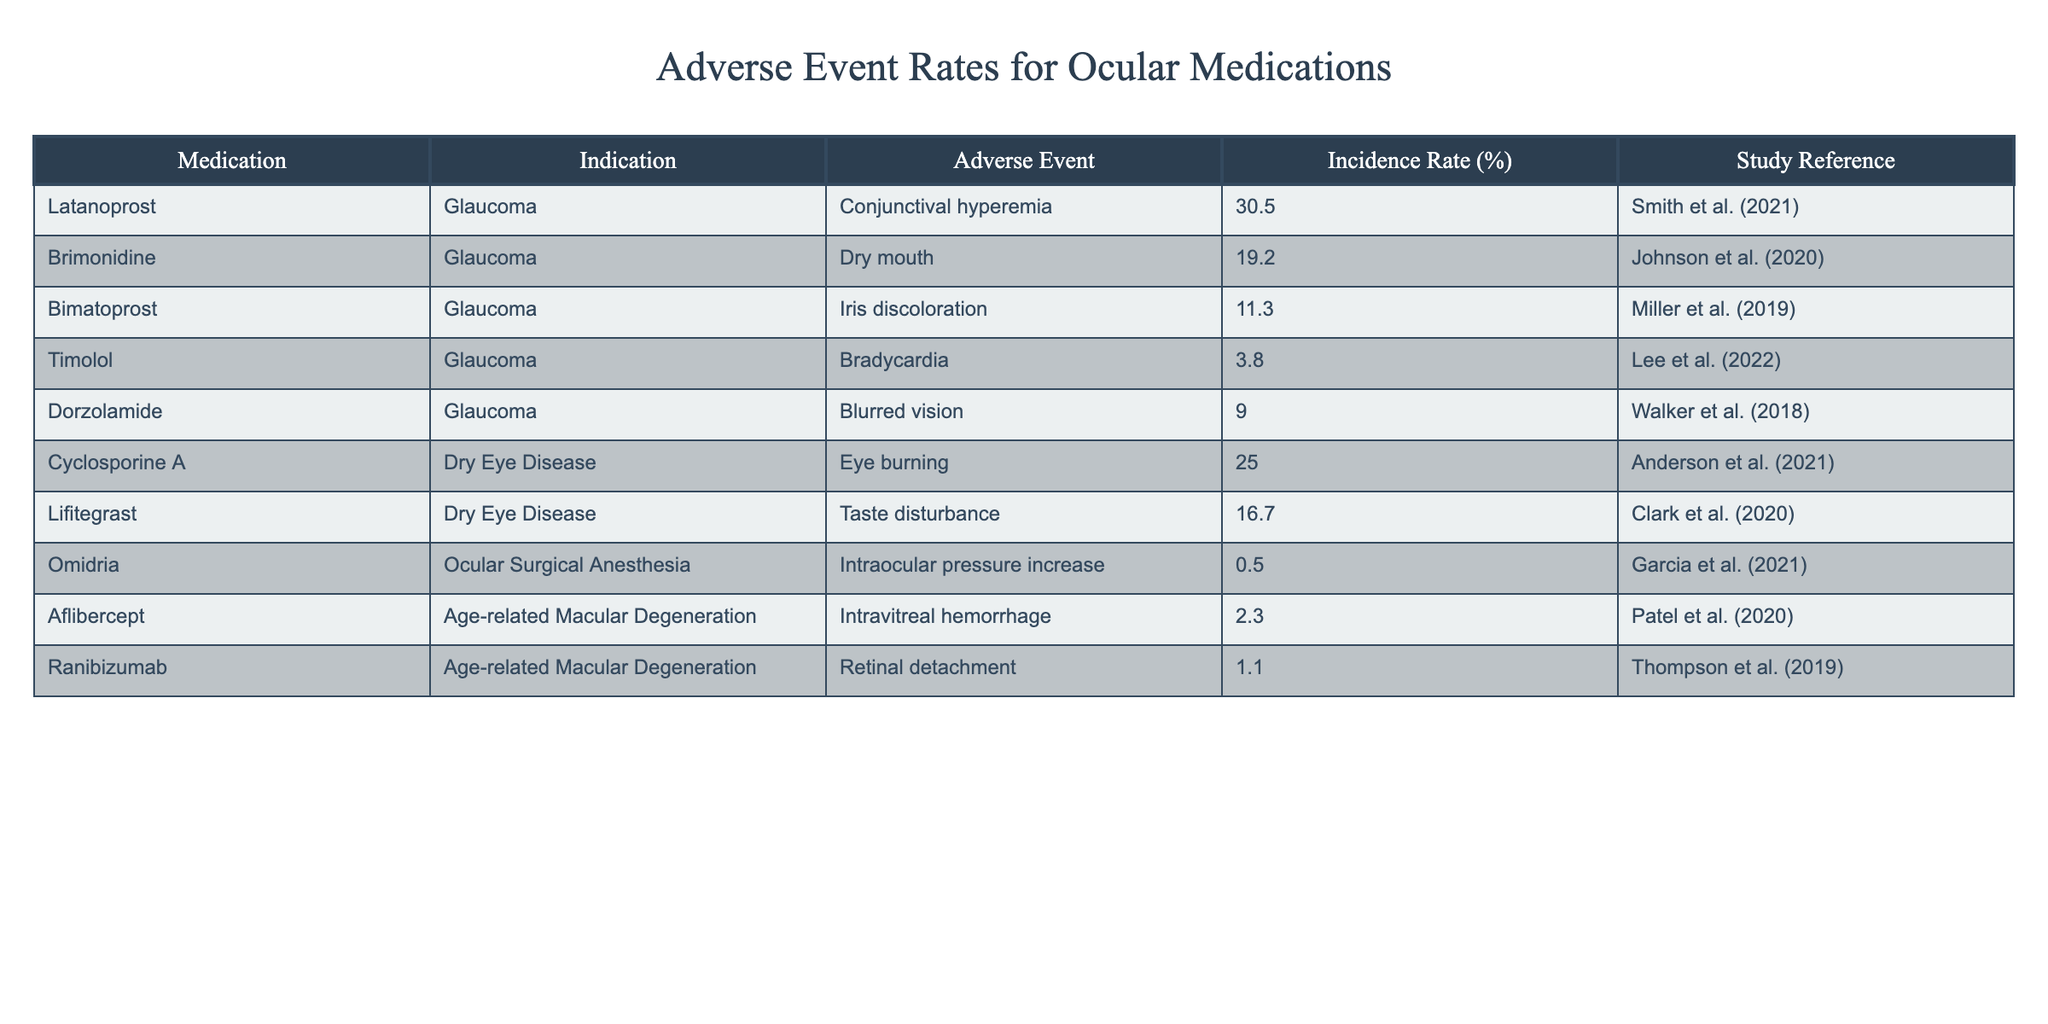What is the incidence rate of conjunctival hyperemia associated with Latanoprost? The table shows that the incidence rate of conjunctival hyperemia, which is an adverse event associated with Latanoprost, is 30.5%.
Answer: 30.5% Which ocular medication has the lowest incidence rate of adverse events, and what is that rate? According to the table, Omidria has the lowest incidence rate of adverse events at 0.5%.
Answer: 0.5% What is the difference in incidence rates between Cyclosporine A and Lifitegrast for their respective adverse events? Cyclosporine A has an incidence rate of 25.0% for eye burning, and Lifitegrast has an incidence rate of 16.7% for taste disturbance. The difference is 25.0% - 16.7% = 8.3%.
Answer: 8.3% Is it true that Ranibizumab has a higher incidence rate of adverse events compared to Timolol? Looking at the table, Ranibizumab has an incidence rate of 1.1% while Timolol has an incidence rate of 3.8%. Since 1.1% is less than 3.8%, the statement is false.
Answer: No What are the two medications listed for glaucoma, and how do their adverse event incidence rates compare? The table shows the medications for glaucoma: Latanoprost (30.5%) and Brimonidine (19.2%). Latanoprost has a higher incidence rate of adverse events compared to Brimonidine.
Answer: Latanoprost has a higher rate What is the total incidence rate of adverse events for all medications indicated for Dry Eye Disease? The incidents for Dry Eye Disease medications are Cyclosporine A (25.0%) and Lifitegrast (16.7%). The total incidence rate is calculated as 25.0% + 16.7% = 41.7%.
Answer: 41.7% Which medication indicated for Age-related Macular Degeneration has the highest incidence rate of adverse events, and what is that rate? Between Aflibercept (2.3%) and Ranibizumab (1.1%), Aflibercept has the highest incidence rate at 2.3%.
Answer: Aflibercept, 2.3% If we took the average of the incidence rates of the four glaucoma medications listed, what would that average be? The incidence rates for the glaucoma medications are: Latanoprost (30.5%), Brimonidine (19.2%), Bimatoprost (11.3%), and Timolol (3.8%). Summing these gives 30.5 + 19.2 + 11.3 + 3.8 = 64.8%. There are 4 medications, so the average is 64.8% / 4 = 16.2%.
Answer: 16.2% 